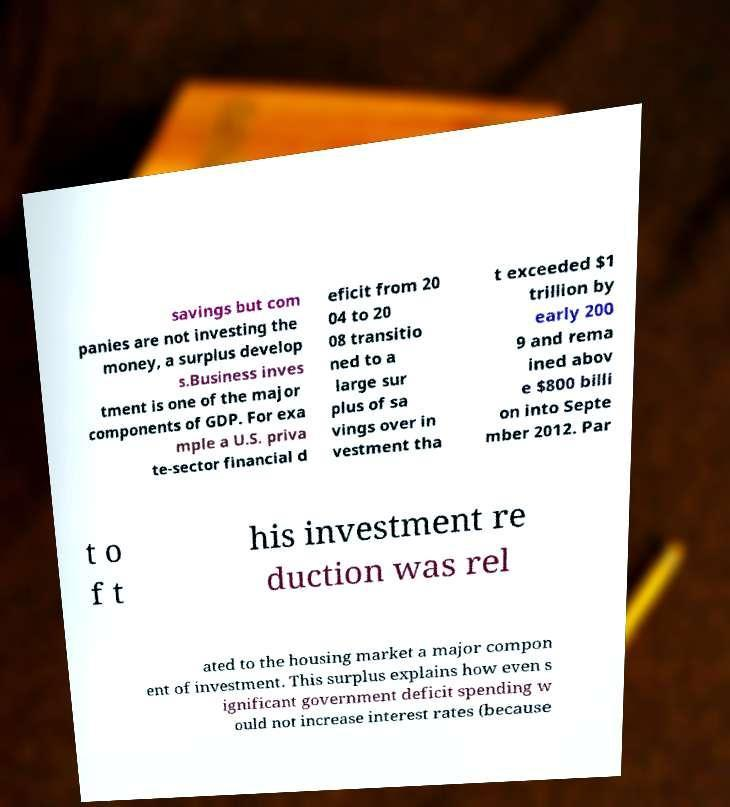I need the written content from this picture converted into text. Can you do that? savings but com panies are not investing the money, a surplus develop s.Business inves tment is one of the major components of GDP. For exa mple a U.S. priva te-sector financial d eficit from 20 04 to 20 08 transitio ned to a large sur plus of sa vings over in vestment tha t exceeded $1 trillion by early 200 9 and rema ined abov e $800 billi on into Septe mber 2012. Par t o f t his investment re duction was rel ated to the housing market a major compon ent of investment. This surplus explains how even s ignificant government deficit spending w ould not increase interest rates (because 